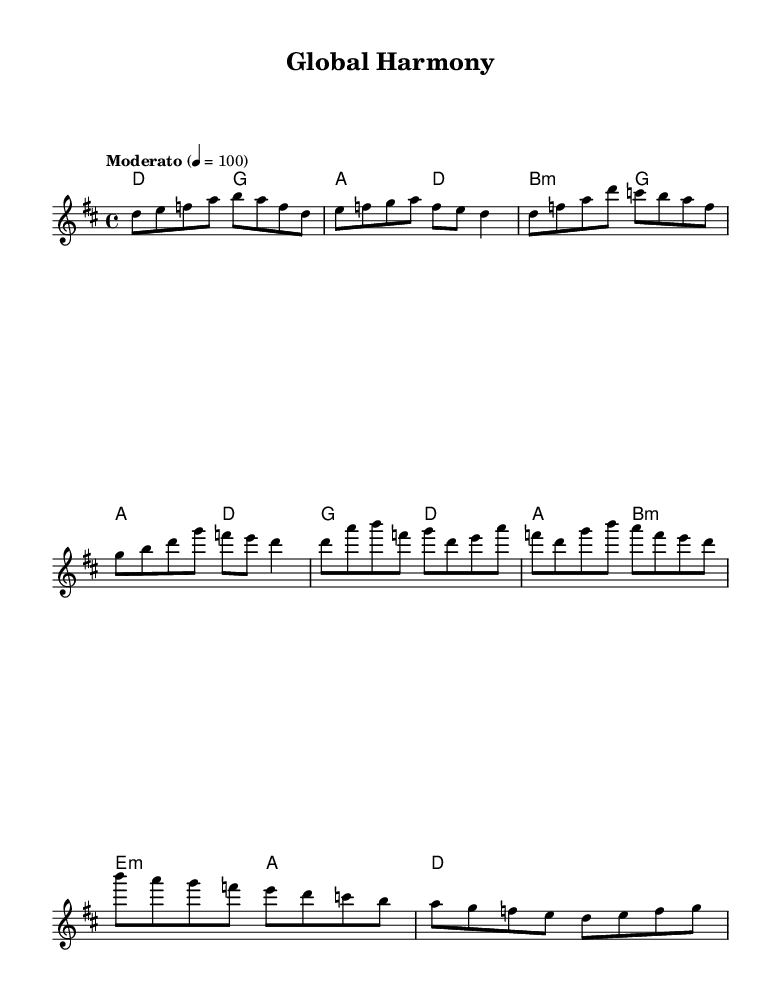What is the key signature of this music? The key signature is D major, which has two sharps (F# and C#). This can be determined by looking at the key signature indicated at the beginning of the score.
Answer: D major What is the time signature of this music? The time signature is 4/4, denoted prominently at the beginning of the score. This means there are four beats in each measure and a quarter note receives one beat.
Answer: 4/4 What is the tempo marking in this music? The tempo marking is "Moderato," which indicates a moderate speed. This is specified in the score where the tempo is indicated alongside the metronome marking of 100.
Answer: Moderato How many measures are there in the chorus section? The chorus section, as seen in the melody part, has 4 measures. By counting the groupings marked by vertical lines in the notation, we find four distinct measures.
Answer: 4 What chords are used in the first two measures of the harmonies? The first two measures consist of the chords D and G. This can be identified by examining the chord names written above the staff at the beginning.
Answer: D, G How does the melody line convey a blend of cultural elements? The melody incorporates intervals and rhythmic patterns common in both Western and Eastern music traditions, symbolizing a fusion of different cultural influences. This reasoning is grounded in how the notes progress and the types of scales that might be implied.
Answer: Cultural fusion What is the overall theme represented by this piece of music? The overall theme represents global population diversity and resource allocation through the blending of various musical elements. This reflects the intertwining cultures and shared experiences of people worldwide as expressed through the composition.
Answer: Global diversity 